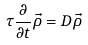Convert formula to latex. <formula><loc_0><loc_0><loc_500><loc_500>\tau \frac { \partial } { \partial t } \vec { \rho } = D \vec { \rho }</formula> 